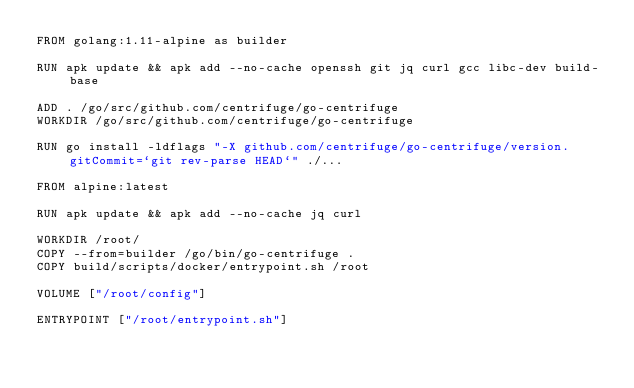<code> <loc_0><loc_0><loc_500><loc_500><_Dockerfile_>FROM golang:1.11-alpine as builder

RUN apk update && apk add --no-cache openssh git jq curl gcc libc-dev build-base

ADD . /go/src/github.com/centrifuge/go-centrifuge
WORKDIR /go/src/github.com/centrifuge/go-centrifuge

RUN go install -ldflags "-X github.com/centrifuge/go-centrifuge/version.gitCommit=`git rev-parse HEAD`" ./...

FROM alpine:latest

RUN apk update && apk add --no-cache jq curl

WORKDIR /root/
COPY --from=builder /go/bin/go-centrifuge .
COPY build/scripts/docker/entrypoint.sh /root

VOLUME ["/root/config"]

ENTRYPOINT ["/root/entrypoint.sh"]


</code> 